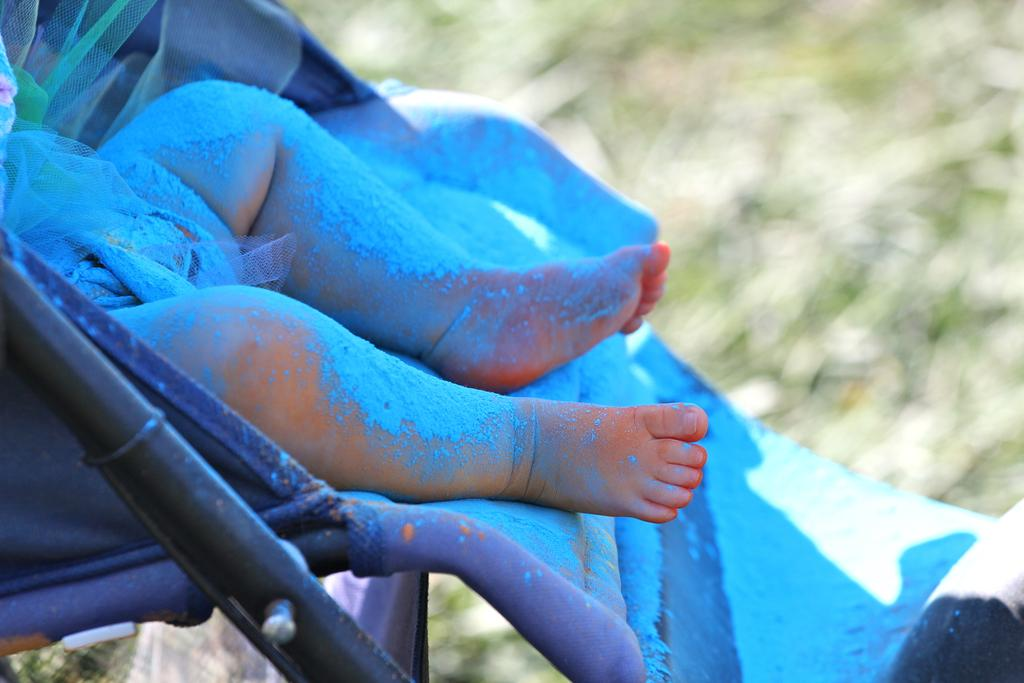What is the main subject of the image? The main subject of the image is a truncated picture of a baby. What object is associated with the baby in the image? There is a baby cart in the image. Can you describe the background of the image? The background of the image is blurred. What type of pig can be seen on the floor in the image? There is no pig present in the image, and the floor is not visible in the image. 